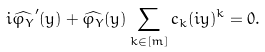<formula> <loc_0><loc_0><loc_500><loc_500>i \widehat { \varphi _ { Y } } ^ { \prime } ( y ) + \widehat { \varphi _ { Y } } ( y ) \sum _ { k \in [ m ] } c _ { k } ( i y ) ^ { k } = 0 .</formula> 